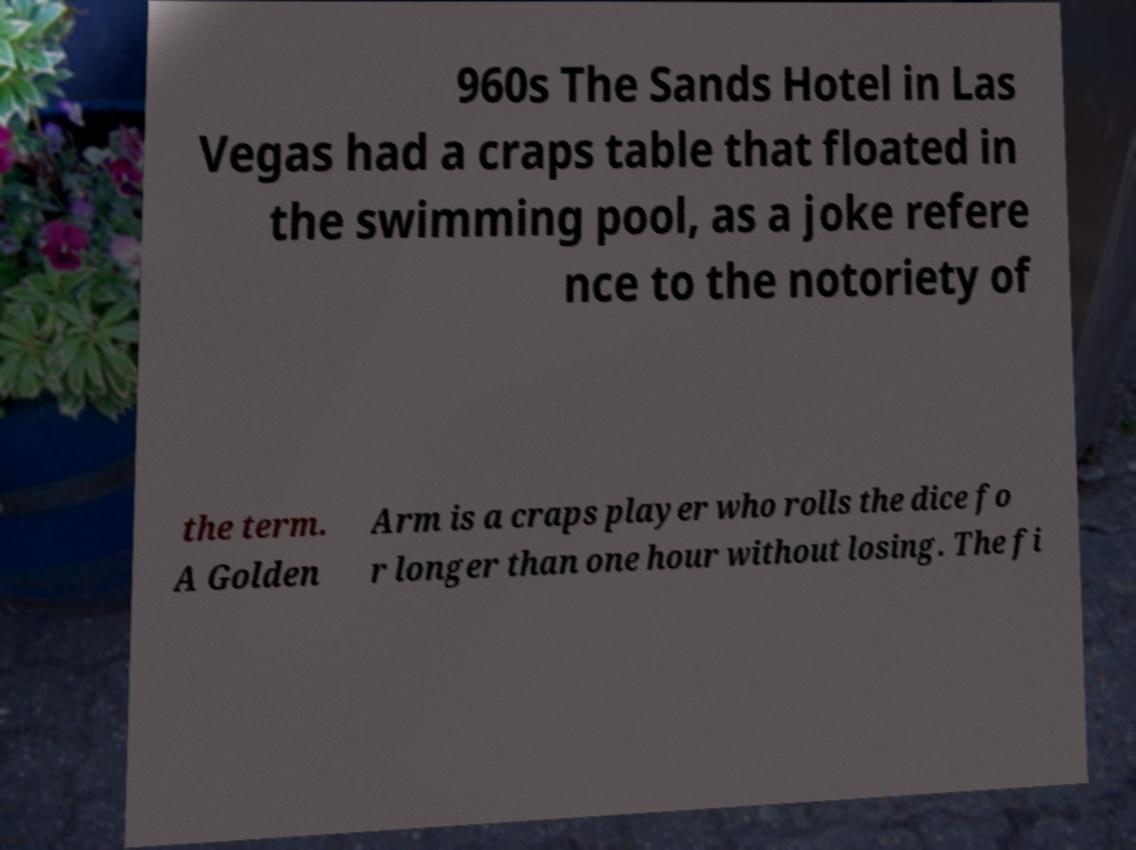Can you accurately transcribe the text from the provided image for me? 960s The Sands Hotel in Las Vegas had a craps table that floated in the swimming pool, as a joke refere nce to the notoriety of the term. A Golden Arm is a craps player who rolls the dice fo r longer than one hour without losing. The fi 